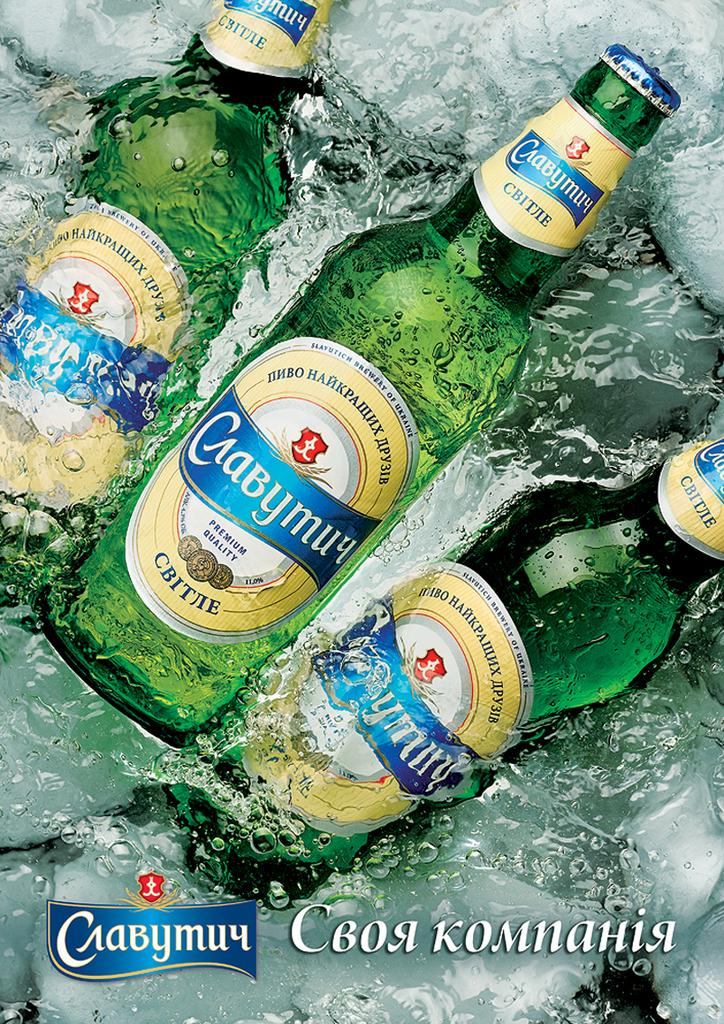<image>
Relay a brief, clear account of the picture shown. Green bottles filled with a premium quality beer sit on ice. 